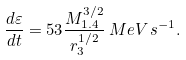Convert formula to latex. <formula><loc_0><loc_0><loc_500><loc_500>\frac { d \varepsilon } { d t } = 5 3 \frac { M _ { 1 . 4 } ^ { 3 / 2 } } { r _ { 3 } ^ { 1 / 2 } } \, M e V \, s ^ { - 1 } .</formula> 